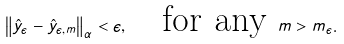Convert formula to latex. <formula><loc_0><loc_0><loc_500><loc_500>\left \| \hat { y } _ { \epsilon } - \hat { y } _ { \epsilon , m } \right \| _ { \alpha } < \epsilon , \quad \text {for any } m > m _ { \epsilon } .</formula> 